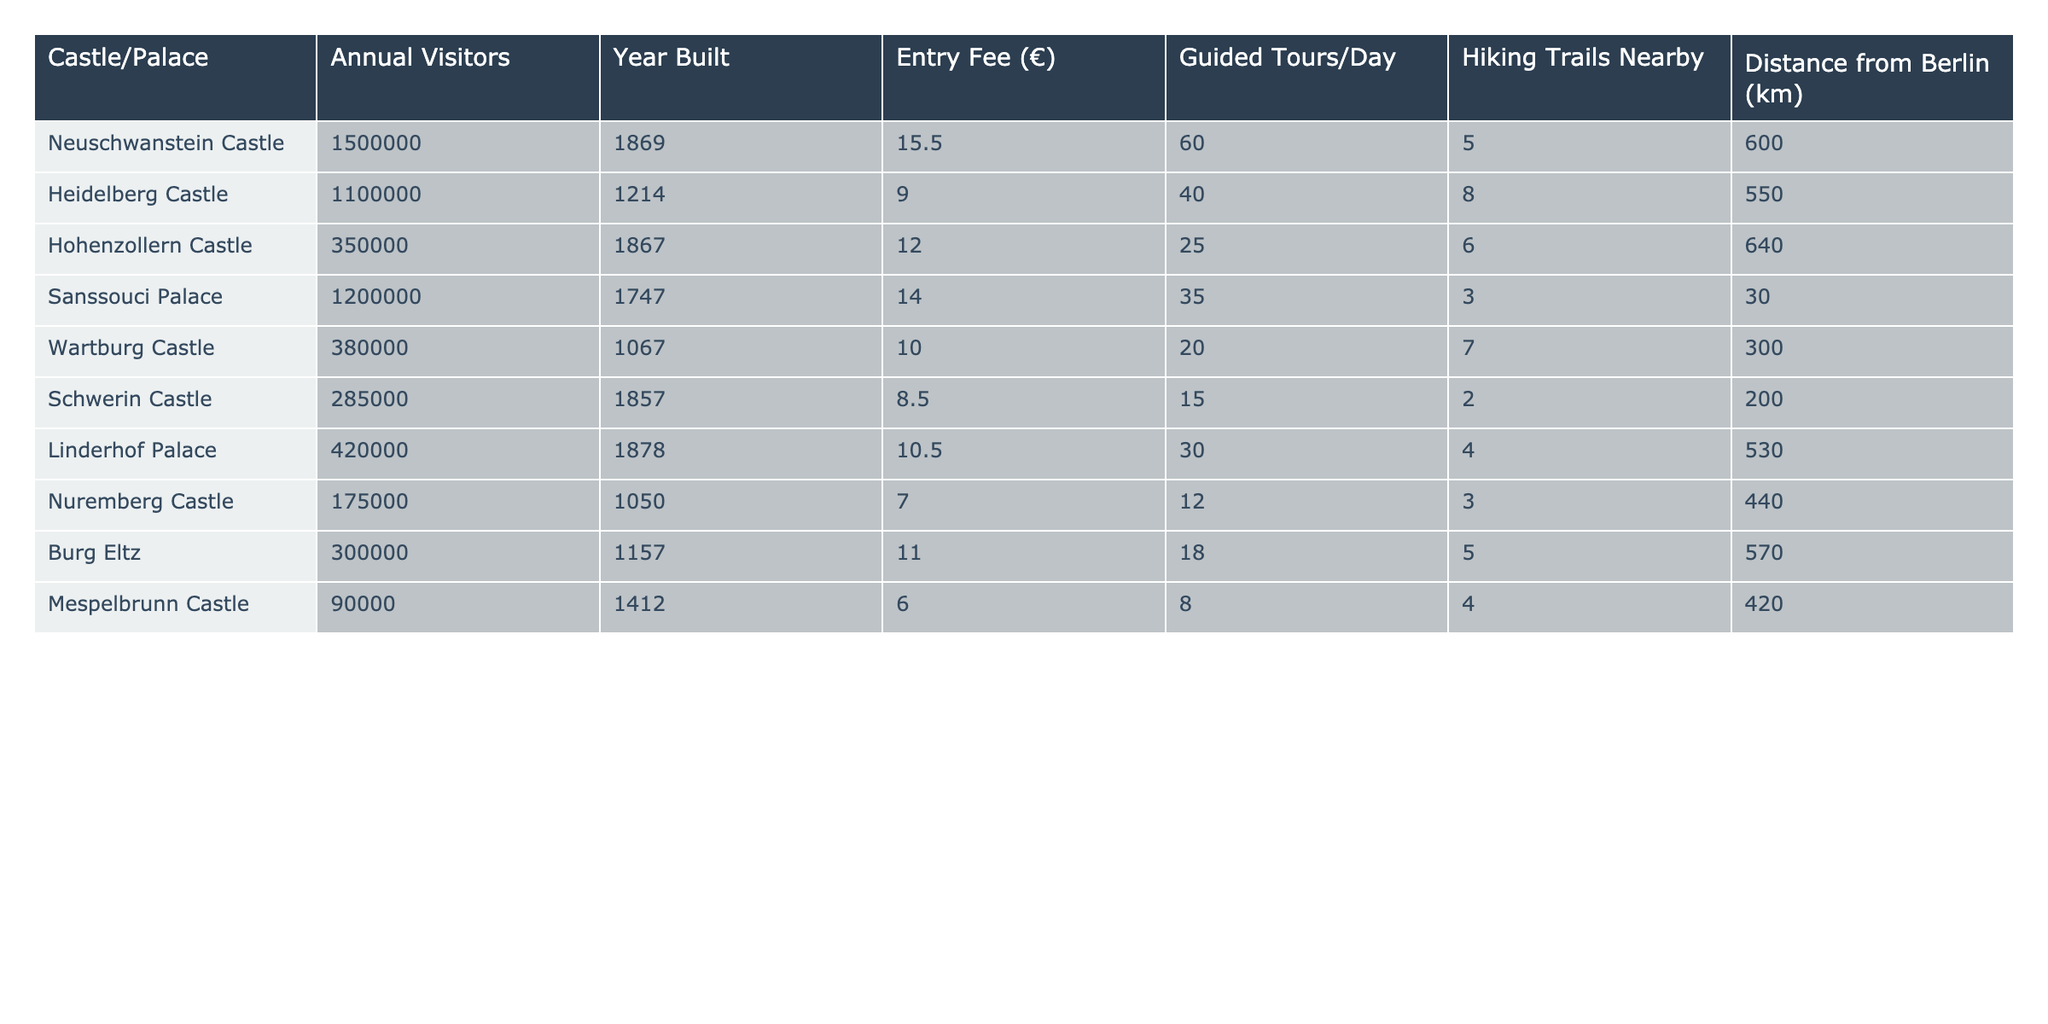What is the entry fee for Neuschwanstein Castle? The entry fee for Neuschwanstein Castle is listed under the "Entry Fee (€)" column. It is 15.5€ according to the table.
Answer: 15.5€ Which castle has the highest number of annual visitors? To find the castle with the highest number of visitors, I will look at the "Annual Visitors" column and identify the maximum value. Neuschwanstein Castle has 1,500,000 annual visitors, which is the highest.
Answer: Neuschwanstein Castle What is the average entry fee for the castles and palaces listed? I sum the entry fees of all the castles (15.5 + 9 + 12 + 14 + 10 + 8.5 + 10.5 + 7 + 11 + 6 = 88.5€) and divide by the number of entries (10). The average entry fee is 88.5/10 = 8.85€.
Answer: 8.85€ Is there a castle that has guided tours available every day? I check the "Guided Tours/Day" column to see if any entry has a value greater than or equal to 1. All listed castles have guided tours available every day, fulfilling the condition.
Answer: Yes Which castle has the most hiking trails nearby and how many are there? I will look at the "Hiking Trails Nearby" column and identify the maximum value. Heidelberg Castle has 8 hiking trails, making it the castle with the most nearby.
Answer: Heidelberg Castle, 8 What is the total distance from Berlin for all the castles combined? I sum all the distances from Berlin (600 + 550 + 640 + 30 + 300 + 200 + 530 + 440 + 570 + 420 = 4030 km) to find the total.
Answer: 4030 km Which castle has the lowest annual visitors and how many? I examine the "Annual Visitors" column to find the minimum value. Mespelbrunn Castle has the lowest with 90,000 annual visitors.
Answer: Mespelbrunn Castle, 90,000 How much more expensive is the entry fee for Sanssouci Palace compared to Hohenzollern Castle? I check the entry fees: Sanssouci Palace is 14€ and Hohenzollern Castle is 12€, so I subtract (14 - 12 = 2). The difference is 2€.
Answer: 2€ If you combine the annual visitors of Linderhof Palace and Wartburg Castle, how many visitors would that be? I will look at the "Annual Visitors" for Linderhof Palace (420,000) and Wartburg Castle (380,000), then sum them (420,000 + 380,000 = 800,000).
Answer: 800,000 Does Schwerin Castle have more then 250,000 annual visitors? I examine the "Annual Visitors" column for Schwerin Castle, which has 285,000. Since this is greater than 250,000, the statement is true.
Answer: Yes 